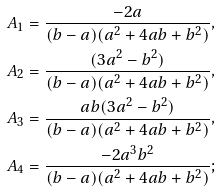Convert formula to latex. <formula><loc_0><loc_0><loc_500><loc_500>& A _ { 1 } = \frac { - 2 a } { ( b - a ) ( a ^ { 2 } + 4 a b + b ^ { 2 } ) } , \\ & A _ { 2 } = \frac { ( 3 a ^ { 2 } - b ^ { 2 } ) } { ( b - a ) ( a ^ { 2 } + 4 a b + b ^ { 2 } ) } , \\ & A _ { 3 } = \frac { a b ( 3 a ^ { 2 } - b ^ { 2 } ) } { ( b - a ) ( a ^ { 2 } + 4 a b + b ^ { 2 } ) } , \\ & A _ { 4 } = \frac { - 2 a ^ { 3 } b ^ { 2 } } { ( b - a ) ( a ^ { 2 } + 4 a b + b ^ { 2 } ) } ;</formula> 